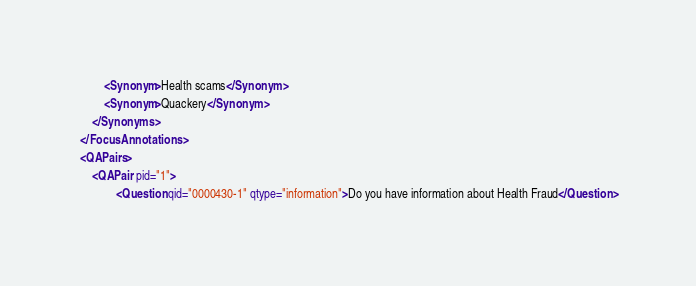Convert code to text. <code><loc_0><loc_0><loc_500><loc_500><_XML_>		<Synonym>Health scams</Synonym>
		<Synonym>Quackery</Synonym>
	</Synonyms>
</FocusAnnotations>
<QAPairs>
	<QAPair pid="1">
			<Question qid="0000430-1" qtype="information">Do you have information about Health Fraud</Question></code> 